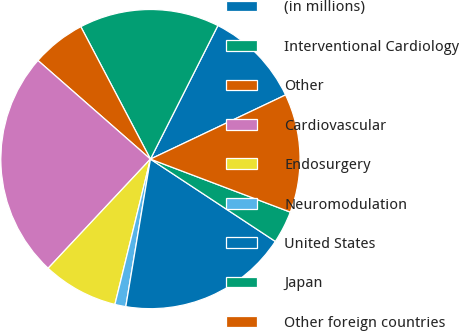Convert chart to OTSL. <chart><loc_0><loc_0><loc_500><loc_500><pie_chart><fcel>(in millions)<fcel>Interventional Cardiology<fcel>Other<fcel>Cardiovascular<fcel>Endosurgery<fcel>Neuromodulation<fcel>United States<fcel>Japan<fcel>Other foreign countries<nl><fcel>10.5%<fcel>15.15%<fcel>5.84%<fcel>24.47%<fcel>8.17%<fcel>1.18%<fcel>18.36%<fcel>3.51%<fcel>12.82%<nl></chart> 